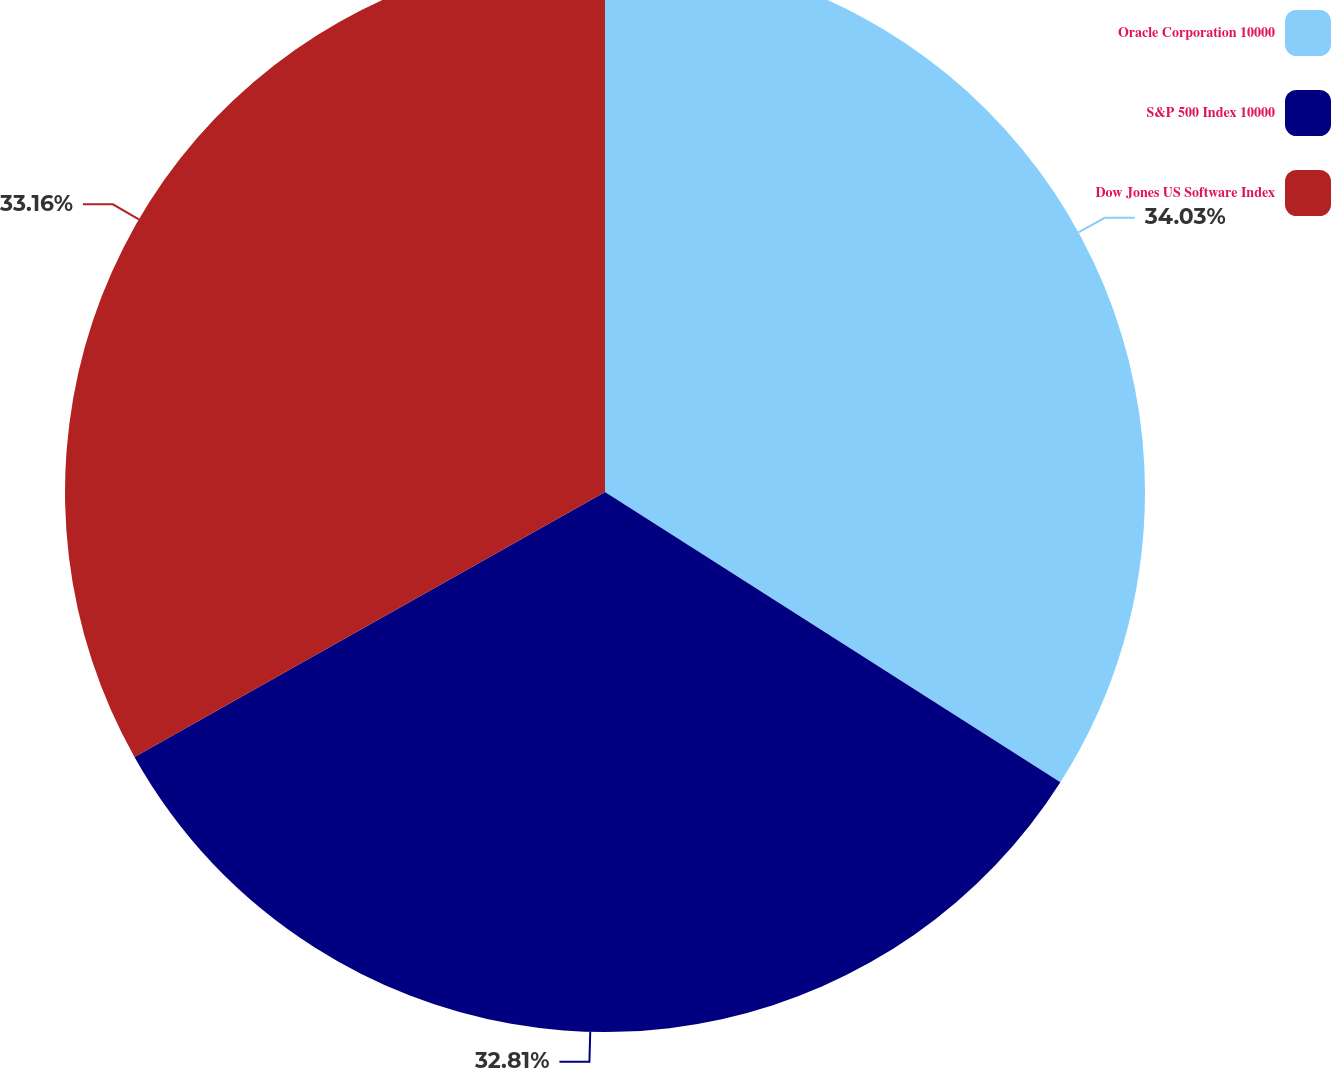Convert chart. <chart><loc_0><loc_0><loc_500><loc_500><pie_chart><fcel>Oracle Corporation 10000<fcel>S&P 500 Index 10000<fcel>Dow Jones US Software Index<nl><fcel>34.03%<fcel>32.81%<fcel>33.16%<nl></chart> 